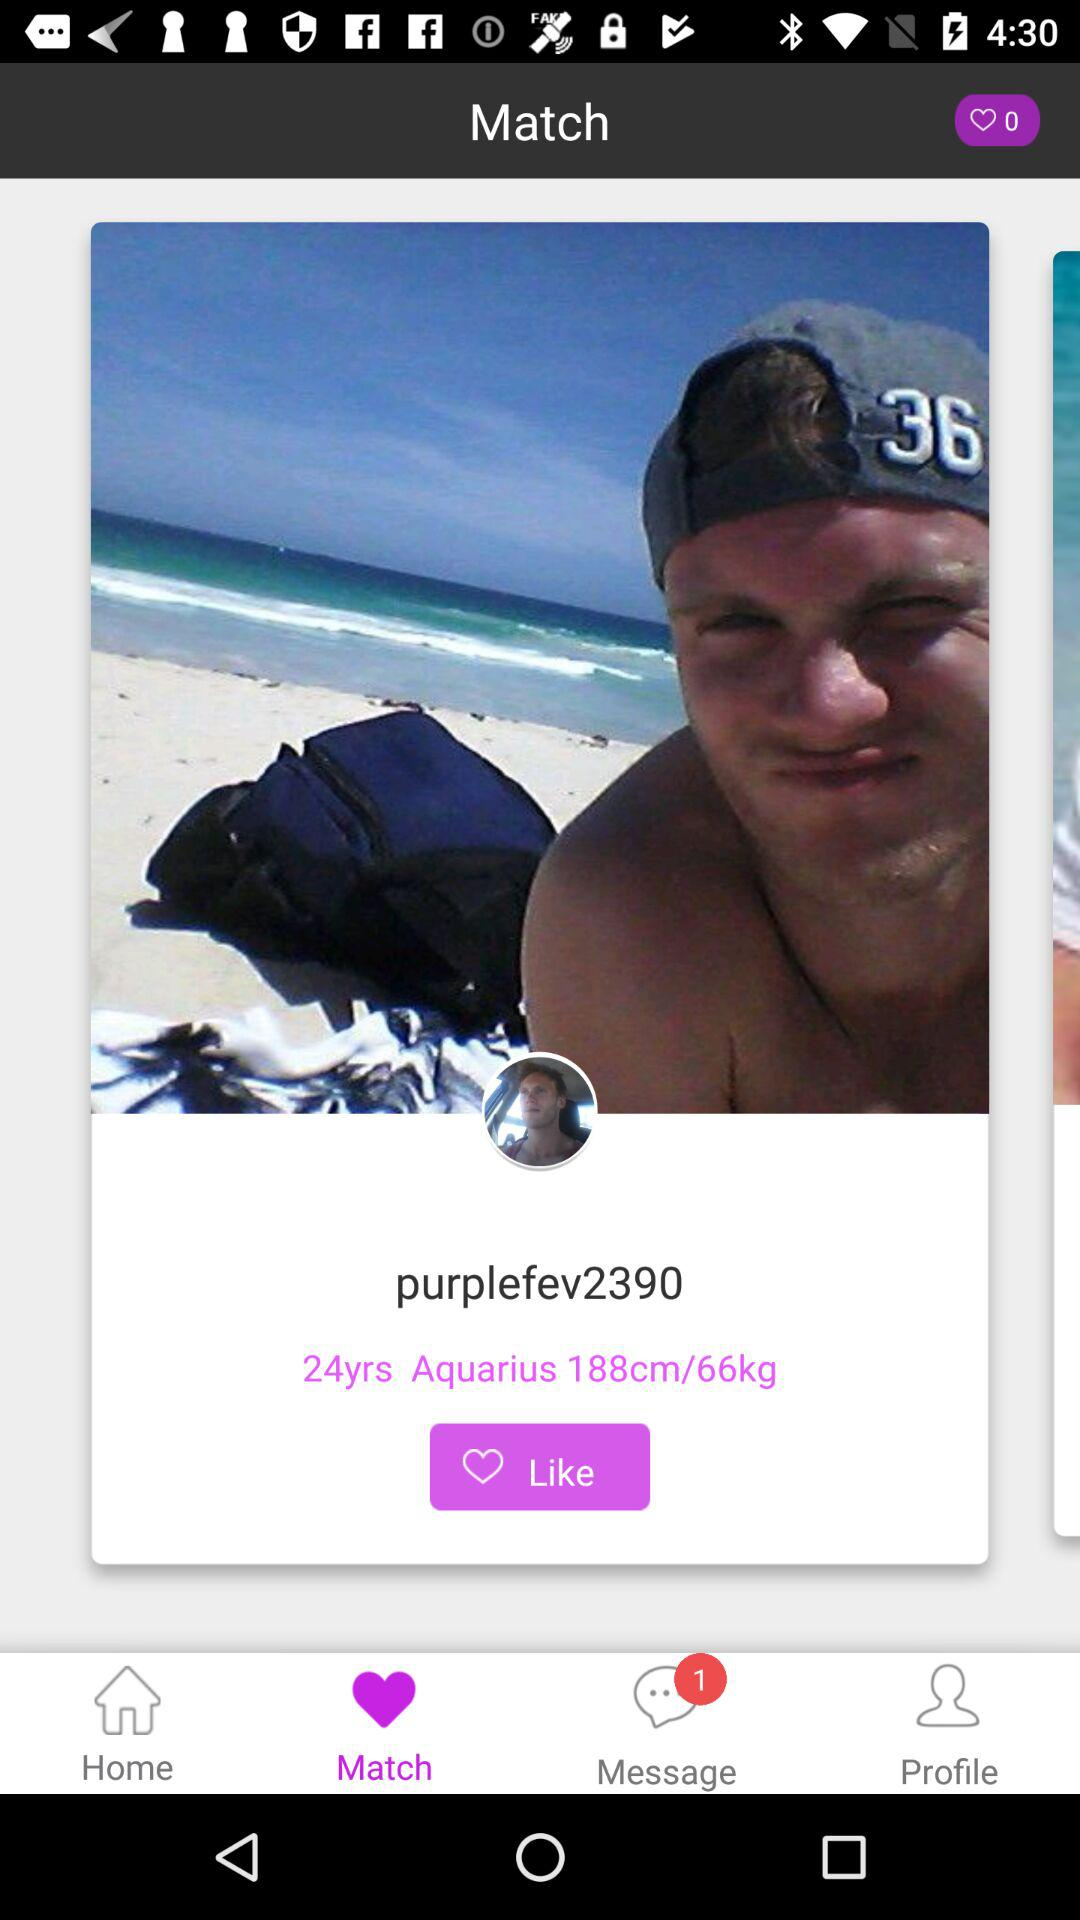What is the user name? The user name is "purplefev2390". 